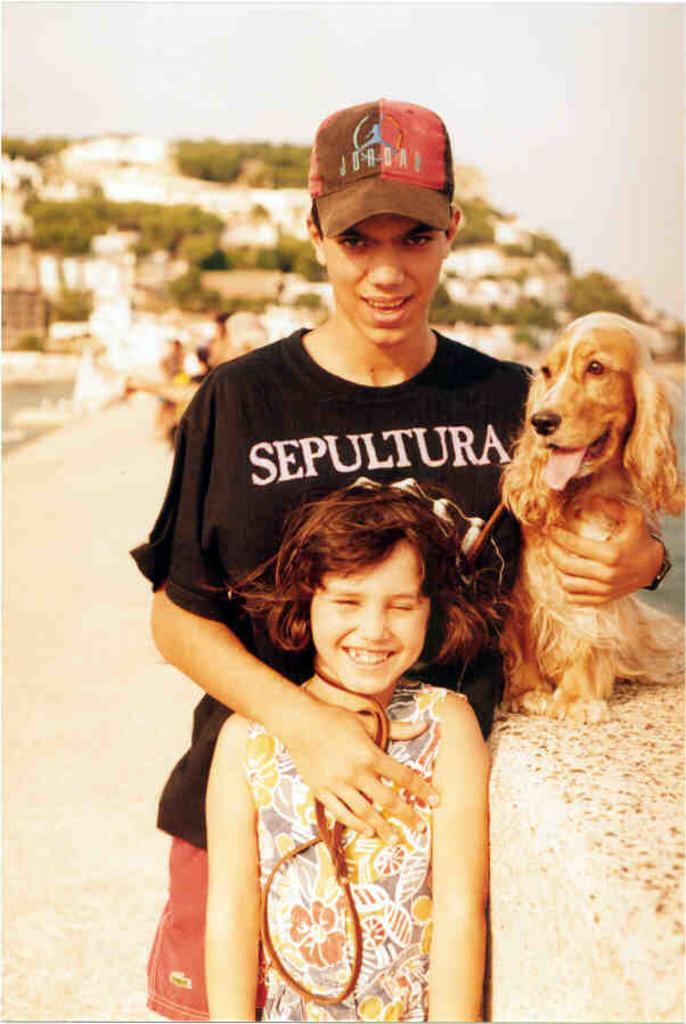Describe this image in one or two sentences. The person wearing black shirt is holding a dog with one of his hands which is on the wall and placed his other hand on a kid in front of him. 